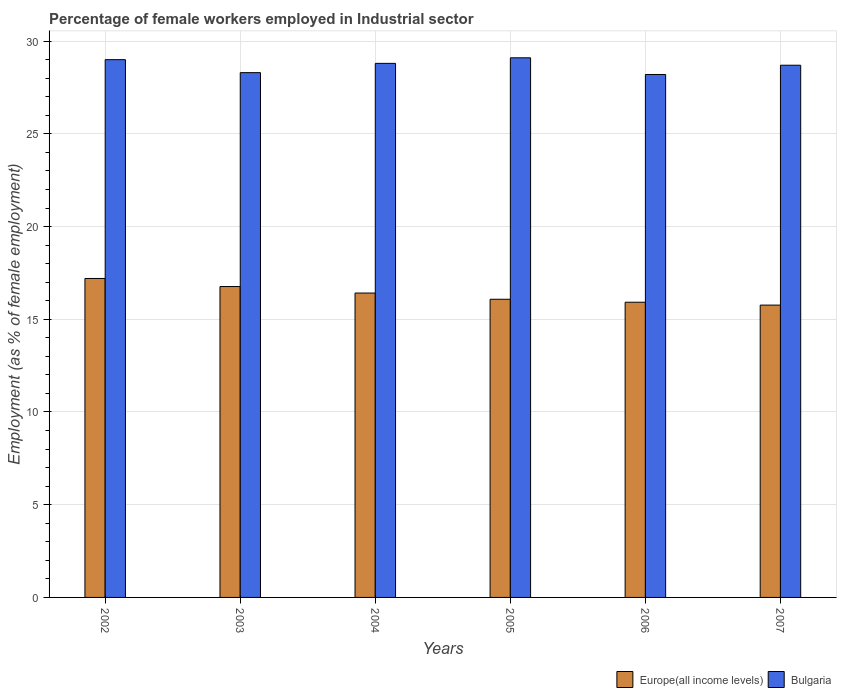How many different coloured bars are there?
Offer a very short reply. 2. What is the label of the 6th group of bars from the left?
Provide a short and direct response. 2007. What is the percentage of females employed in Industrial sector in Europe(all income levels) in 2003?
Your response must be concise. 16.77. Across all years, what is the maximum percentage of females employed in Industrial sector in Bulgaria?
Ensure brevity in your answer.  29.1. Across all years, what is the minimum percentage of females employed in Industrial sector in Europe(all income levels)?
Offer a terse response. 15.76. In which year was the percentage of females employed in Industrial sector in Europe(all income levels) maximum?
Keep it short and to the point. 2002. What is the total percentage of females employed in Industrial sector in Europe(all income levels) in the graph?
Give a very brief answer. 98.14. What is the difference between the percentage of females employed in Industrial sector in Europe(all income levels) in 2003 and that in 2006?
Give a very brief answer. 0.85. What is the difference between the percentage of females employed in Industrial sector in Europe(all income levels) in 2007 and the percentage of females employed in Industrial sector in Bulgaria in 2002?
Offer a very short reply. -13.24. What is the average percentage of females employed in Industrial sector in Europe(all income levels) per year?
Your response must be concise. 16.36. In the year 2003, what is the difference between the percentage of females employed in Industrial sector in Europe(all income levels) and percentage of females employed in Industrial sector in Bulgaria?
Provide a succinct answer. -11.53. What is the ratio of the percentage of females employed in Industrial sector in Europe(all income levels) in 2002 to that in 2004?
Your answer should be very brief. 1.05. Is the difference between the percentage of females employed in Industrial sector in Europe(all income levels) in 2003 and 2006 greater than the difference between the percentage of females employed in Industrial sector in Bulgaria in 2003 and 2006?
Offer a very short reply. Yes. What is the difference between the highest and the second highest percentage of females employed in Industrial sector in Bulgaria?
Give a very brief answer. 0.1. What is the difference between the highest and the lowest percentage of females employed in Industrial sector in Europe(all income levels)?
Provide a succinct answer. 1.44. What does the 1st bar from the left in 2002 represents?
Offer a terse response. Europe(all income levels). What does the 2nd bar from the right in 2004 represents?
Offer a terse response. Europe(all income levels). Are all the bars in the graph horizontal?
Offer a terse response. No. How many years are there in the graph?
Your answer should be compact. 6. Are the values on the major ticks of Y-axis written in scientific E-notation?
Your response must be concise. No. How are the legend labels stacked?
Your answer should be very brief. Horizontal. What is the title of the graph?
Offer a terse response. Percentage of female workers employed in Industrial sector. What is the label or title of the X-axis?
Provide a short and direct response. Years. What is the label or title of the Y-axis?
Offer a very short reply. Employment (as % of female employment). What is the Employment (as % of female employment) in Europe(all income levels) in 2002?
Provide a short and direct response. 17.2. What is the Employment (as % of female employment) of Bulgaria in 2002?
Give a very brief answer. 29. What is the Employment (as % of female employment) of Europe(all income levels) in 2003?
Provide a short and direct response. 16.77. What is the Employment (as % of female employment) in Bulgaria in 2003?
Make the answer very short. 28.3. What is the Employment (as % of female employment) in Europe(all income levels) in 2004?
Your response must be concise. 16.41. What is the Employment (as % of female employment) in Bulgaria in 2004?
Your response must be concise. 28.8. What is the Employment (as % of female employment) of Europe(all income levels) in 2005?
Provide a succinct answer. 16.08. What is the Employment (as % of female employment) of Bulgaria in 2005?
Your answer should be compact. 29.1. What is the Employment (as % of female employment) in Europe(all income levels) in 2006?
Your response must be concise. 15.92. What is the Employment (as % of female employment) in Bulgaria in 2006?
Offer a very short reply. 28.2. What is the Employment (as % of female employment) in Europe(all income levels) in 2007?
Offer a very short reply. 15.76. What is the Employment (as % of female employment) of Bulgaria in 2007?
Give a very brief answer. 28.7. Across all years, what is the maximum Employment (as % of female employment) of Europe(all income levels)?
Provide a succinct answer. 17.2. Across all years, what is the maximum Employment (as % of female employment) of Bulgaria?
Offer a very short reply. 29.1. Across all years, what is the minimum Employment (as % of female employment) of Europe(all income levels)?
Your answer should be compact. 15.76. Across all years, what is the minimum Employment (as % of female employment) of Bulgaria?
Offer a terse response. 28.2. What is the total Employment (as % of female employment) in Europe(all income levels) in the graph?
Give a very brief answer. 98.14. What is the total Employment (as % of female employment) of Bulgaria in the graph?
Keep it short and to the point. 172.1. What is the difference between the Employment (as % of female employment) of Europe(all income levels) in 2002 and that in 2003?
Ensure brevity in your answer.  0.43. What is the difference between the Employment (as % of female employment) of Bulgaria in 2002 and that in 2003?
Offer a very short reply. 0.7. What is the difference between the Employment (as % of female employment) in Europe(all income levels) in 2002 and that in 2004?
Provide a short and direct response. 0.79. What is the difference between the Employment (as % of female employment) of Bulgaria in 2002 and that in 2004?
Make the answer very short. 0.2. What is the difference between the Employment (as % of female employment) in Europe(all income levels) in 2002 and that in 2005?
Your answer should be very brief. 1.12. What is the difference between the Employment (as % of female employment) in Europe(all income levels) in 2002 and that in 2006?
Offer a terse response. 1.28. What is the difference between the Employment (as % of female employment) in Europe(all income levels) in 2002 and that in 2007?
Your answer should be very brief. 1.44. What is the difference between the Employment (as % of female employment) of Europe(all income levels) in 2003 and that in 2004?
Keep it short and to the point. 0.35. What is the difference between the Employment (as % of female employment) of Bulgaria in 2003 and that in 2004?
Give a very brief answer. -0.5. What is the difference between the Employment (as % of female employment) in Europe(all income levels) in 2003 and that in 2005?
Offer a terse response. 0.69. What is the difference between the Employment (as % of female employment) in Bulgaria in 2003 and that in 2005?
Ensure brevity in your answer.  -0.8. What is the difference between the Employment (as % of female employment) of Europe(all income levels) in 2003 and that in 2006?
Provide a succinct answer. 0.85. What is the difference between the Employment (as % of female employment) of Europe(all income levels) in 2003 and that in 2007?
Offer a terse response. 1. What is the difference between the Employment (as % of female employment) in Europe(all income levels) in 2004 and that in 2005?
Provide a short and direct response. 0.34. What is the difference between the Employment (as % of female employment) in Bulgaria in 2004 and that in 2005?
Provide a short and direct response. -0.3. What is the difference between the Employment (as % of female employment) in Europe(all income levels) in 2004 and that in 2006?
Ensure brevity in your answer.  0.5. What is the difference between the Employment (as % of female employment) of Europe(all income levels) in 2004 and that in 2007?
Ensure brevity in your answer.  0.65. What is the difference between the Employment (as % of female employment) in Bulgaria in 2004 and that in 2007?
Your response must be concise. 0.1. What is the difference between the Employment (as % of female employment) in Europe(all income levels) in 2005 and that in 2006?
Offer a terse response. 0.16. What is the difference between the Employment (as % of female employment) in Bulgaria in 2005 and that in 2006?
Your answer should be very brief. 0.9. What is the difference between the Employment (as % of female employment) in Europe(all income levels) in 2005 and that in 2007?
Make the answer very short. 0.32. What is the difference between the Employment (as % of female employment) of Bulgaria in 2005 and that in 2007?
Your response must be concise. 0.4. What is the difference between the Employment (as % of female employment) in Europe(all income levels) in 2006 and that in 2007?
Make the answer very short. 0.16. What is the difference between the Employment (as % of female employment) of Europe(all income levels) in 2002 and the Employment (as % of female employment) of Bulgaria in 2003?
Keep it short and to the point. -11.1. What is the difference between the Employment (as % of female employment) in Europe(all income levels) in 2002 and the Employment (as % of female employment) in Bulgaria in 2004?
Provide a succinct answer. -11.6. What is the difference between the Employment (as % of female employment) of Europe(all income levels) in 2002 and the Employment (as % of female employment) of Bulgaria in 2005?
Provide a short and direct response. -11.9. What is the difference between the Employment (as % of female employment) in Europe(all income levels) in 2002 and the Employment (as % of female employment) in Bulgaria in 2006?
Provide a succinct answer. -11. What is the difference between the Employment (as % of female employment) in Europe(all income levels) in 2002 and the Employment (as % of female employment) in Bulgaria in 2007?
Provide a succinct answer. -11.5. What is the difference between the Employment (as % of female employment) of Europe(all income levels) in 2003 and the Employment (as % of female employment) of Bulgaria in 2004?
Keep it short and to the point. -12.03. What is the difference between the Employment (as % of female employment) of Europe(all income levels) in 2003 and the Employment (as % of female employment) of Bulgaria in 2005?
Keep it short and to the point. -12.33. What is the difference between the Employment (as % of female employment) in Europe(all income levels) in 2003 and the Employment (as % of female employment) in Bulgaria in 2006?
Your answer should be very brief. -11.43. What is the difference between the Employment (as % of female employment) in Europe(all income levels) in 2003 and the Employment (as % of female employment) in Bulgaria in 2007?
Ensure brevity in your answer.  -11.93. What is the difference between the Employment (as % of female employment) of Europe(all income levels) in 2004 and the Employment (as % of female employment) of Bulgaria in 2005?
Offer a terse response. -12.69. What is the difference between the Employment (as % of female employment) of Europe(all income levels) in 2004 and the Employment (as % of female employment) of Bulgaria in 2006?
Your response must be concise. -11.79. What is the difference between the Employment (as % of female employment) in Europe(all income levels) in 2004 and the Employment (as % of female employment) in Bulgaria in 2007?
Your response must be concise. -12.29. What is the difference between the Employment (as % of female employment) of Europe(all income levels) in 2005 and the Employment (as % of female employment) of Bulgaria in 2006?
Offer a very short reply. -12.12. What is the difference between the Employment (as % of female employment) in Europe(all income levels) in 2005 and the Employment (as % of female employment) in Bulgaria in 2007?
Your response must be concise. -12.62. What is the difference between the Employment (as % of female employment) of Europe(all income levels) in 2006 and the Employment (as % of female employment) of Bulgaria in 2007?
Offer a very short reply. -12.78. What is the average Employment (as % of female employment) in Europe(all income levels) per year?
Your answer should be very brief. 16.36. What is the average Employment (as % of female employment) in Bulgaria per year?
Provide a short and direct response. 28.68. In the year 2002, what is the difference between the Employment (as % of female employment) of Europe(all income levels) and Employment (as % of female employment) of Bulgaria?
Provide a short and direct response. -11.8. In the year 2003, what is the difference between the Employment (as % of female employment) of Europe(all income levels) and Employment (as % of female employment) of Bulgaria?
Your answer should be very brief. -11.53. In the year 2004, what is the difference between the Employment (as % of female employment) of Europe(all income levels) and Employment (as % of female employment) of Bulgaria?
Offer a very short reply. -12.39. In the year 2005, what is the difference between the Employment (as % of female employment) in Europe(all income levels) and Employment (as % of female employment) in Bulgaria?
Ensure brevity in your answer.  -13.02. In the year 2006, what is the difference between the Employment (as % of female employment) in Europe(all income levels) and Employment (as % of female employment) in Bulgaria?
Your answer should be compact. -12.28. In the year 2007, what is the difference between the Employment (as % of female employment) in Europe(all income levels) and Employment (as % of female employment) in Bulgaria?
Your answer should be compact. -12.94. What is the ratio of the Employment (as % of female employment) in Europe(all income levels) in 2002 to that in 2003?
Give a very brief answer. 1.03. What is the ratio of the Employment (as % of female employment) in Bulgaria in 2002 to that in 2003?
Provide a short and direct response. 1.02. What is the ratio of the Employment (as % of female employment) in Europe(all income levels) in 2002 to that in 2004?
Give a very brief answer. 1.05. What is the ratio of the Employment (as % of female employment) of Bulgaria in 2002 to that in 2004?
Give a very brief answer. 1.01. What is the ratio of the Employment (as % of female employment) of Europe(all income levels) in 2002 to that in 2005?
Keep it short and to the point. 1.07. What is the ratio of the Employment (as % of female employment) in Europe(all income levels) in 2002 to that in 2006?
Make the answer very short. 1.08. What is the ratio of the Employment (as % of female employment) in Bulgaria in 2002 to that in 2006?
Your answer should be compact. 1.03. What is the ratio of the Employment (as % of female employment) in Europe(all income levels) in 2002 to that in 2007?
Ensure brevity in your answer.  1.09. What is the ratio of the Employment (as % of female employment) in Bulgaria in 2002 to that in 2007?
Your answer should be very brief. 1.01. What is the ratio of the Employment (as % of female employment) of Europe(all income levels) in 2003 to that in 2004?
Provide a succinct answer. 1.02. What is the ratio of the Employment (as % of female employment) of Bulgaria in 2003 to that in 2004?
Provide a succinct answer. 0.98. What is the ratio of the Employment (as % of female employment) in Europe(all income levels) in 2003 to that in 2005?
Make the answer very short. 1.04. What is the ratio of the Employment (as % of female employment) in Bulgaria in 2003 to that in 2005?
Keep it short and to the point. 0.97. What is the ratio of the Employment (as % of female employment) of Europe(all income levels) in 2003 to that in 2006?
Offer a terse response. 1.05. What is the ratio of the Employment (as % of female employment) in Europe(all income levels) in 2003 to that in 2007?
Make the answer very short. 1.06. What is the ratio of the Employment (as % of female employment) in Bulgaria in 2003 to that in 2007?
Your answer should be very brief. 0.99. What is the ratio of the Employment (as % of female employment) in Europe(all income levels) in 2004 to that in 2005?
Provide a succinct answer. 1.02. What is the ratio of the Employment (as % of female employment) in Europe(all income levels) in 2004 to that in 2006?
Keep it short and to the point. 1.03. What is the ratio of the Employment (as % of female employment) of Bulgaria in 2004 to that in 2006?
Keep it short and to the point. 1.02. What is the ratio of the Employment (as % of female employment) of Europe(all income levels) in 2004 to that in 2007?
Ensure brevity in your answer.  1.04. What is the ratio of the Employment (as % of female employment) of Bulgaria in 2004 to that in 2007?
Give a very brief answer. 1. What is the ratio of the Employment (as % of female employment) of Bulgaria in 2005 to that in 2006?
Provide a succinct answer. 1.03. What is the ratio of the Employment (as % of female employment) in Europe(all income levels) in 2005 to that in 2007?
Give a very brief answer. 1.02. What is the ratio of the Employment (as % of female employment) in Bulgaria in 2005 to that in 2007?
Offer a very short reply. 1.01. What is the ratio of the Employment (as % of female employment) in Europe(all income levels) in 2006 to that in 2007?
Your response must be concise. 1.01. What is the ratio of the Employment (as % of female employment) in Bulgaria in 2006 to that in 2007?
Provide a succinct answer. 0.98. What is the difference between the highest and the second highest Employment (as % of female employment) in Europe(all income levels)?
Give a very brief answer. 0.43. What is the difference between the highest and the lowest Employment (as % of female employment) of Europe(all income levels)?
Offer a very short reply. 1.44. 